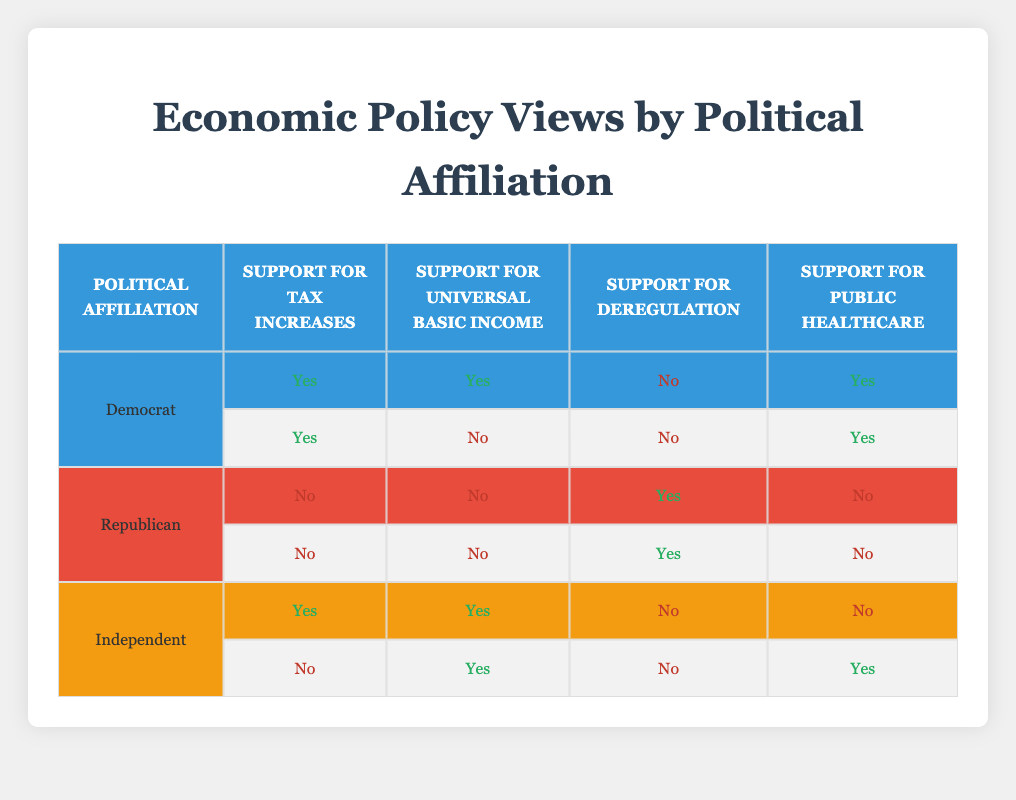What is the total number of Democrats who support tax increases? In the table, under the "Democrat" category, there are two entries: one supporting tax increases (Yes) and another also supporting tax increases (Yes). Therefore, the total count of Democrats supporting tax increases is 2.
Answer: 2 How many Republicans support deregulation? There are two entries for Republicans, and both of them indicate support for deregulation (Yes). Thus, the total count of Republicans supporting deregulation is 2.
Answer: 2 Do Independents show support for public healthcare? In the table, there are two entries for Independents. The first entry indicates "No" for support of public healthcare, while the second entry indicates "Yes". Thus, whether Independents show support for public healthcare varies and one out of the two supports it.
Answer: Yes What percentage of Democrats support universal basic income? There are two Democrats in the table, one supports universal basic income (Yes) and one does not (No). To calculate the percentage, the formula is (number of supporters/total number of entries) * 100. This calculates as (1/2) * 100, giving us a percentage of 50%.
Answer: 50% Is there any political affiliation that shows unanimous support for tax increases? Looking at the table, Democrats have 2 supports for tax increases whereas Independents have one "Yes" and one "No." Republicans do not support tax increases at all. Since no group has unanimous support, the answer is no.
Answer: No What is the ratio of support for universal basic income between Democrats and Republicans? Currently, Democrats have 1 Yes to 1 No for universal basic income; therefore, their ratio is 1:1. Republicans have 0 Yes to 2 No for universal basic income, giving them a ratio of 0:2. This does not carry forward for the ratio but clearly indicates that Democrats support it more than Republicans.
Answer: 1:0 Which political affiliation has the highest number of "Yes" responses across all economic policies? To assess this, we need to count "Yes" responses for each group. Democrats: 4 Yeses (Tax increases, UBI, Public healthcare) against 0 No. Republicans have 0 Yeses and 4 Noes. Independents have 3 Yeses. Therefore, Democrats have the highest with 4 Yes responses.
Answer: Democrats If all Independents supported public healthcare, what would be the new total count of support for public healthcare? Currently, Independents show 1 Yes and 1 No for public healthcare. If all Independents supported it (changing to 2 Yes), adding that to the current counts from Democrats (2 Yes), the total for public healthcare would be 4 Yes (2 from Democrats and 2 from Independents).
Answer: 4 